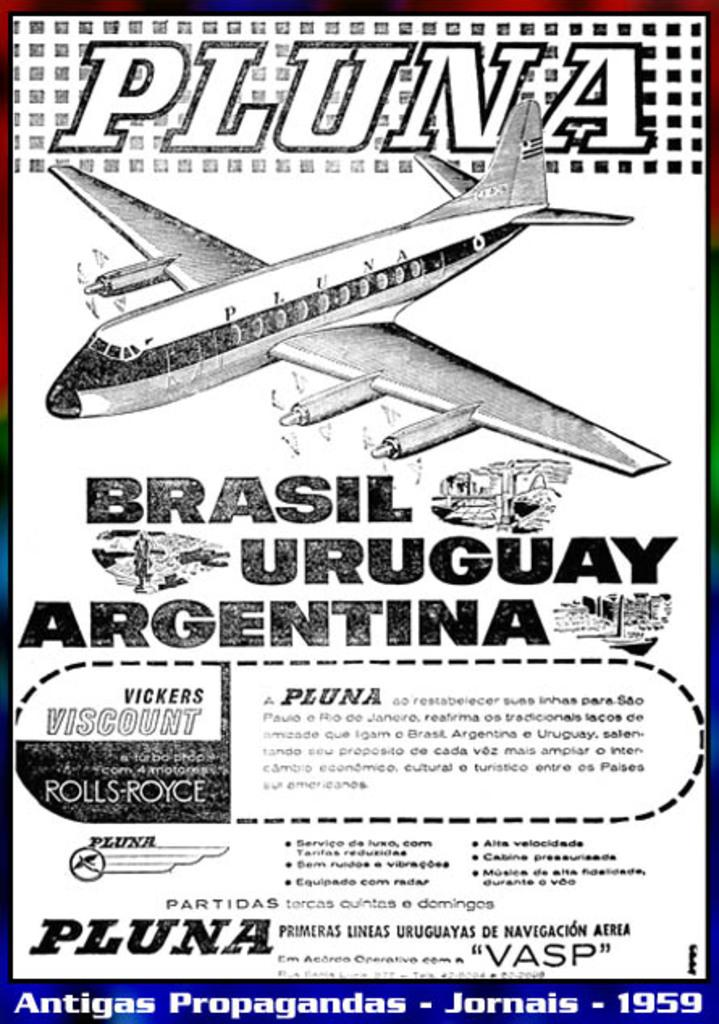<image>
Give a short and clear explanation of the subsequent image. A 1959 advert showing a prop powered jet which can take you to Brazil, Uruguay and Argentina. 